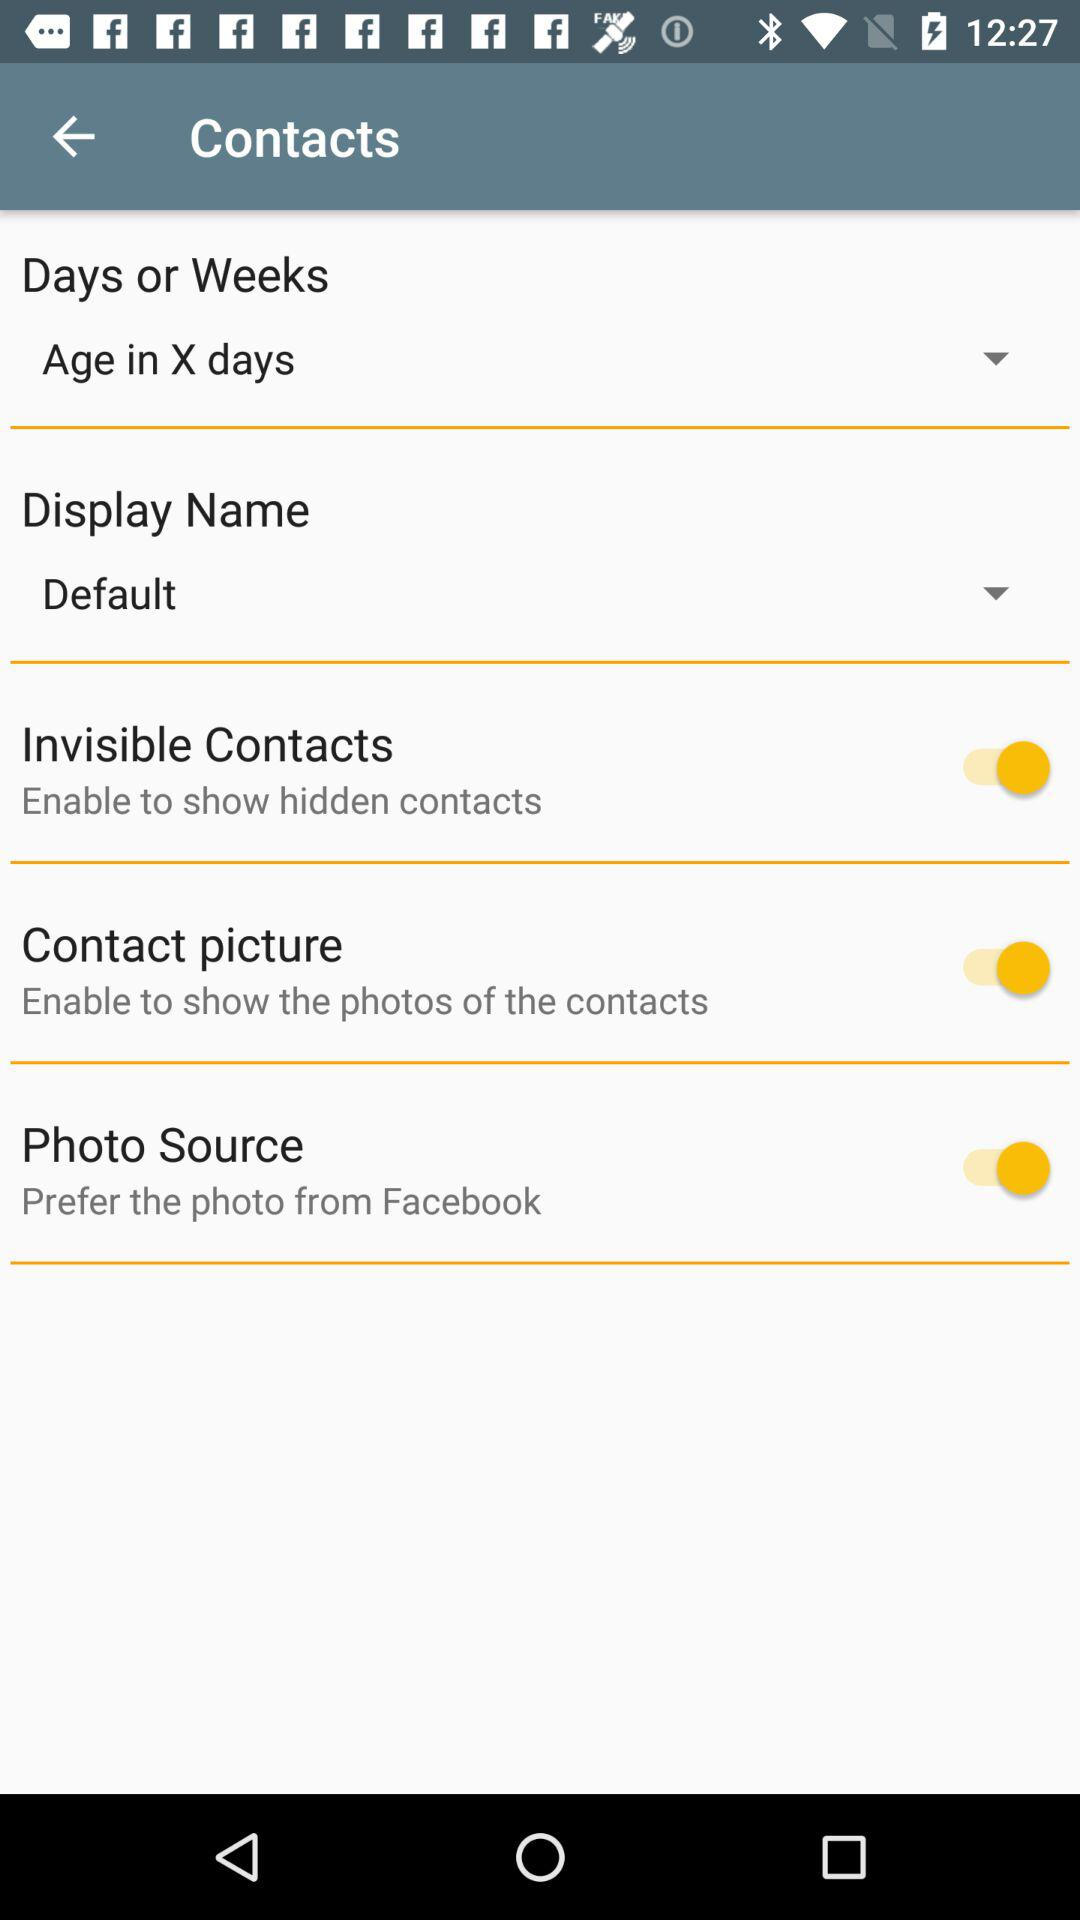Which option is selected in "Days or Weeks" setting? The selected option is "Age in X days". 